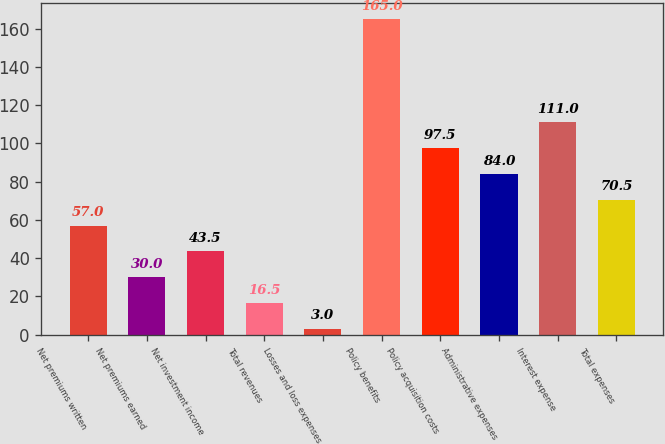Convert chart to OTSL. <chart><loc_0><loc_0><loc_500><loc_500><bar_chart><fcel>Net premiums written<fcel>Net premiums earned<fcel>Net investment income<fcel>Total revenues<fcel>Losses and loss expenses<fcel>Policy benefits<fcel>Policy acquisition costs<fcel>Administrative expenses<fcel>Interest expense<fcel>Total expenses<nl><fcel>57<fcel>30<fcel>43.5<fcel>16.5<fcel>3<fcel>165<fcel>97.5<fcel>84<fcel>111<fcel>70.5<nl></chart> 